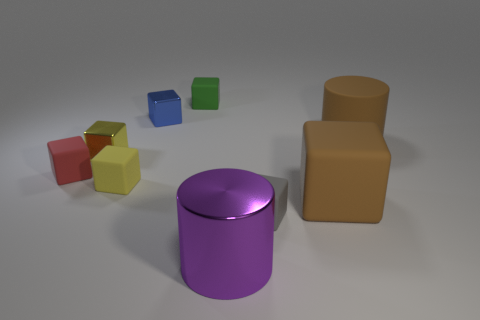There is another shiny block that is the same size as the blue cube; what color is it?
Provide a short and direct response. Yellow. There is a small object that is right of the large thing that is in front of the gray rubber thing; what is its shape?
Your answer should be compact. Cube. Do the cylinder that is behind the purple metallic cylinder and the big purple shiny object have the same size?
Provide a succinct answer. Yes. What number of other objects are there of the same material as the tiny gray cube?
Your answer should be compact. 5. What number of green things are big rubber things or tiny shiny things?
Ensure brevity in your answer.  0. What size is the matte cylinder that is the same color as the large cube?
Make the answer very short. Large. What number of large objects are behind the tiny blue cube?
Ensure brevity in your answer.  0. There is a shiny thing to the right of the thing that is behind the metallic thing that is behind the big brown cylinder; what is its size?
Provide a succinct answer. Large. Is there a blue cube right of the large cylinder that is left of the tiny block to the right of the green rubber object?
Your answer should be very brief. No. Are there more large rubber cylinders than tiny gray cylinders?
Provide a succinct answer. Yes. 